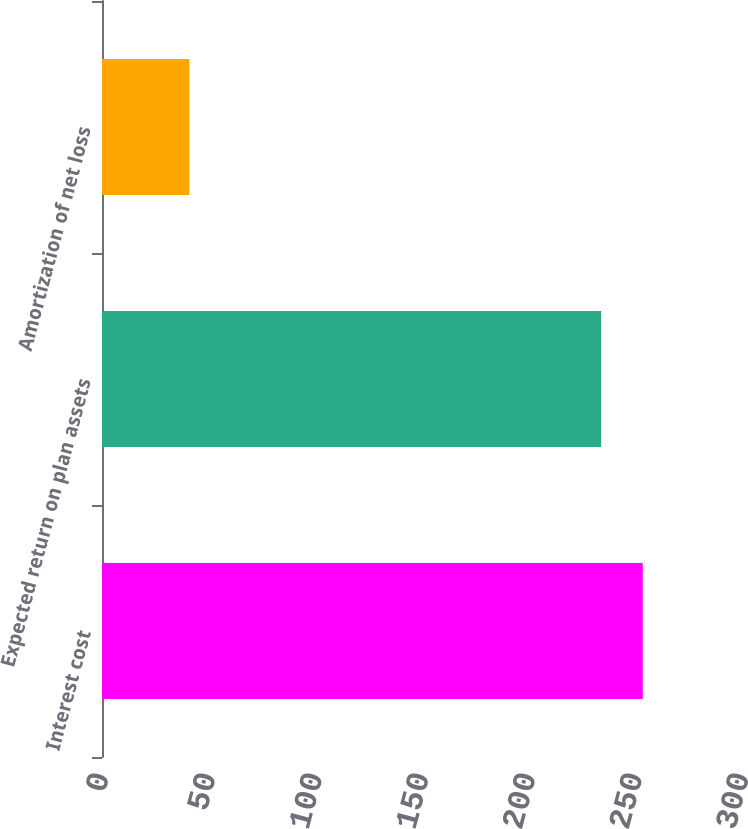Convert chart to OTSL. <chart><loc_0><loc_0><loc_500><loc_500><bar_chart><fcel>Interest cost<fcel>Expected return on plan assets<fcel>Amortization of net loss<nl><fcel>253.5<fcel>234<fcel>41<nl></chart> 